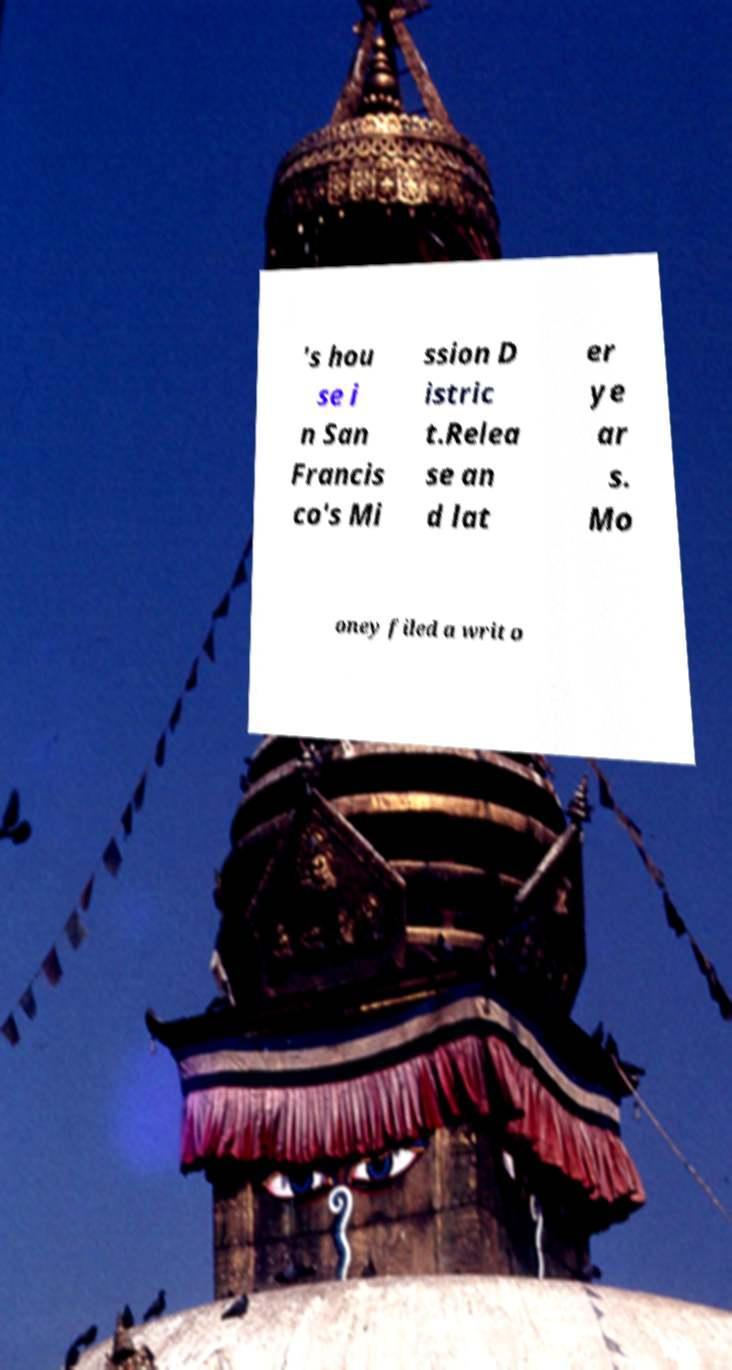For documentation purposes, I need the text within this image transcribed. Could you provide that? 's hou se i n San Francis co's Mi ssion D istric t.Relea se an d lat er ye ar s. Mo oney filed a writ o 